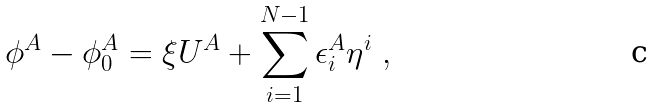<formula> <loc_0><loc_0><loc_500><loc_500>\phi ^ { A } - \phi ^ { A } _ { 0 } = \xi U ^ { A } + \sum _ { i = 1 } ^ { N - 1 } \epsilon _ { i } ^ { A } \eta ^ { i } \ ,</formula> 